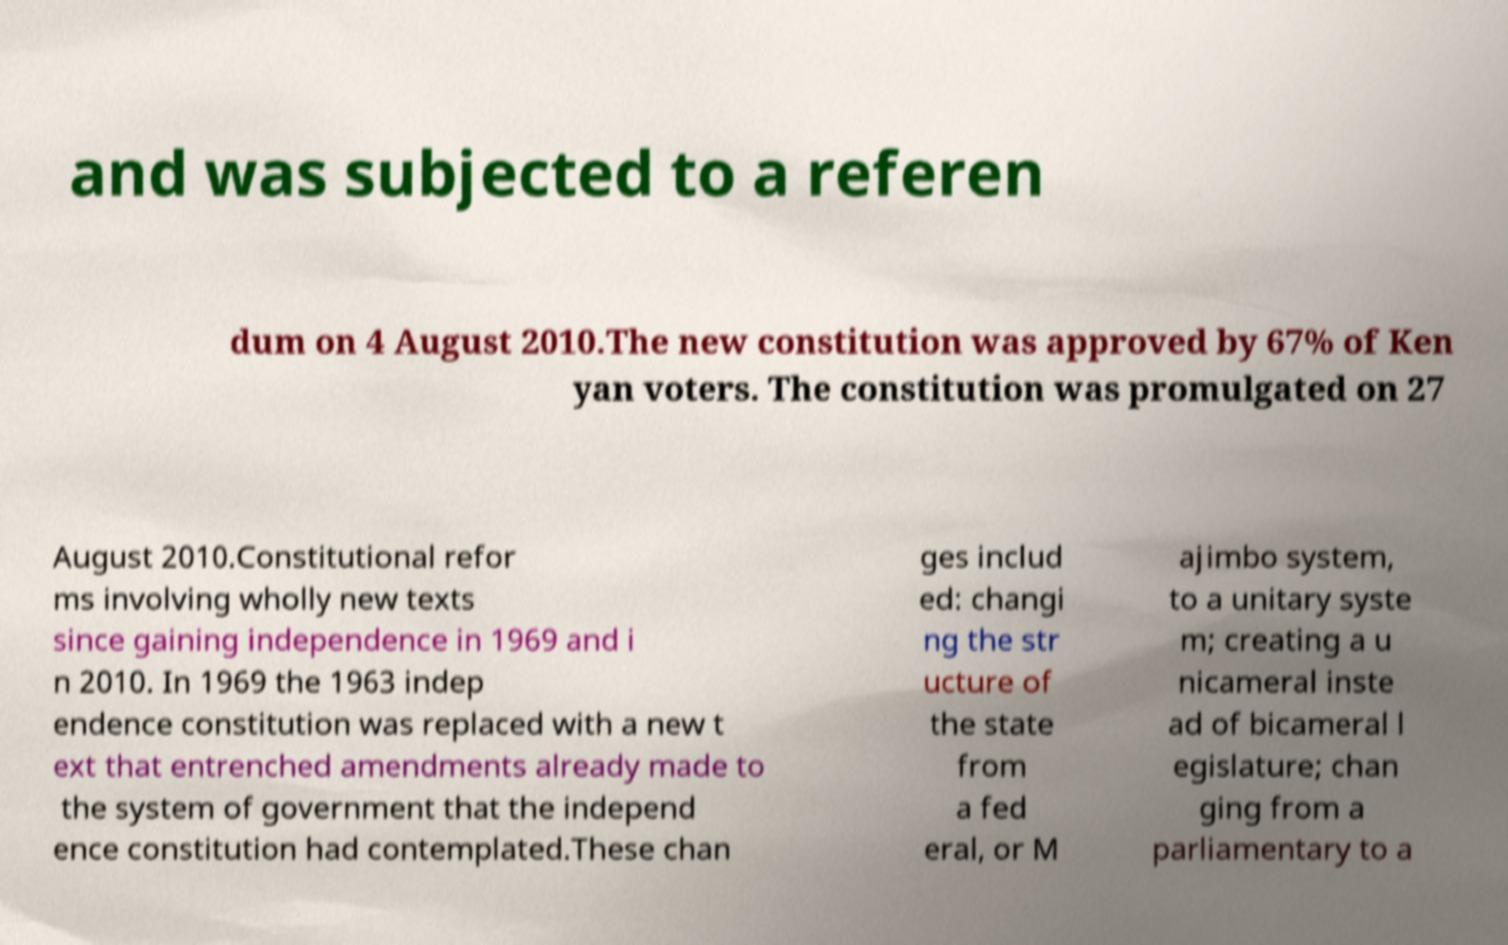Could you extract and type out the text from this image? and was subjected to a referen dum on 4 August 2010.The new constitution was approved by 67% of Ken yan voters. The constitution was promulgated on 27 August 2010.Constitutional refor ms involving wholly new texts since gaining independence in 1969 and i n 2010. In 1969 the 1963 indep endence constitution was replaced with a new t ext that entrenched amendments already made to the system of government that the independ ence constitution had contemplated.These chan ges includ ed: changi ng the str ucture of the state from a fed eral, or M ajimbo system, to a unitary syste m; creating a u nicameral inste ad of bicameral l egislature; chan ging from a parliamentary to a 